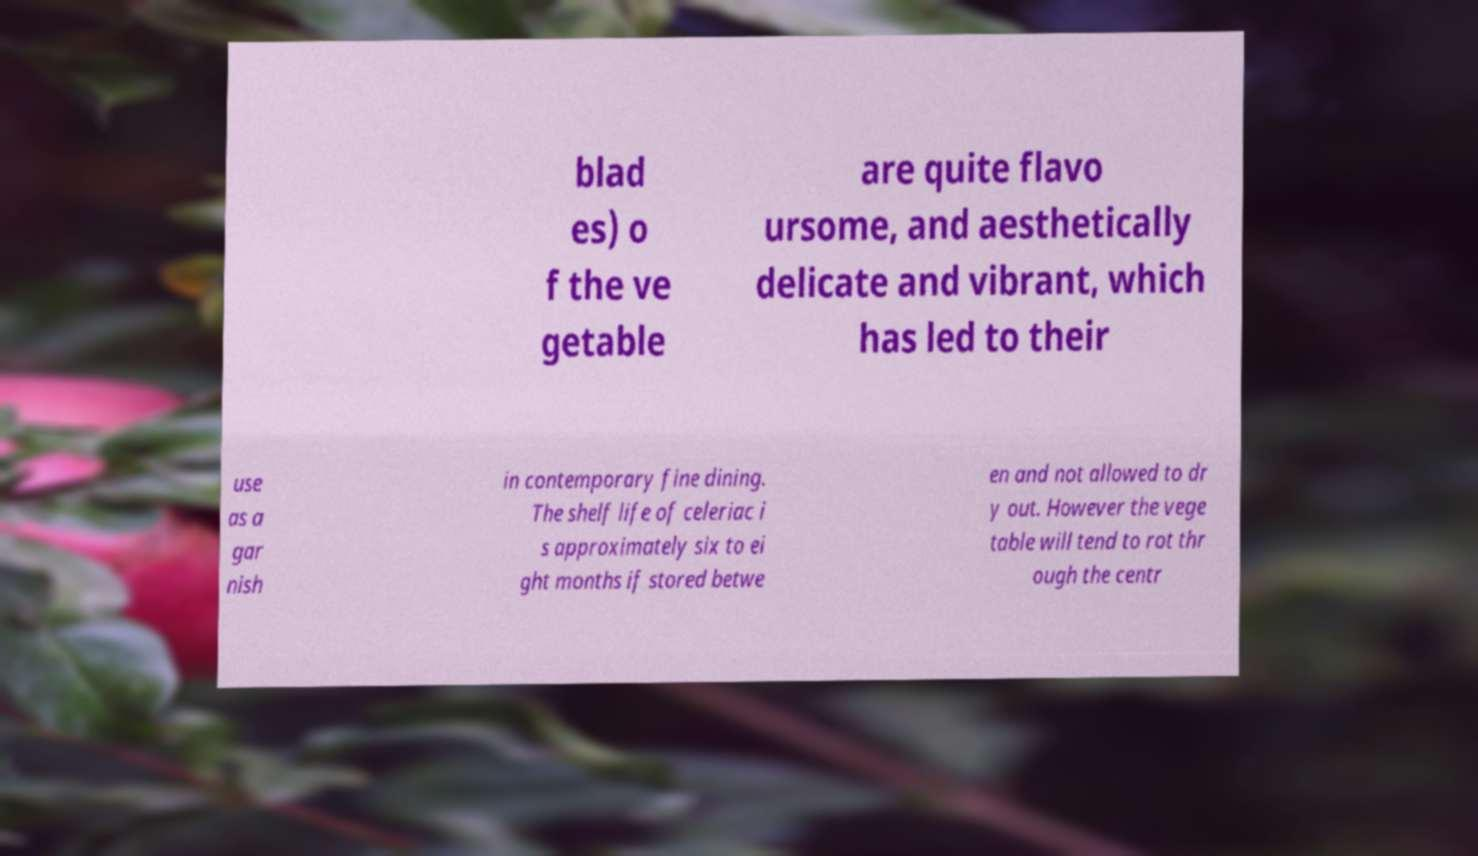Can you accurately transcribe the text from the provided image for me? blad es) o f the ve getable are quite flavo ursome, and aesthetically delicate and vibrant, which has led to their use as a gar nish in contemporary fine dining. The shelf life of celeriac i s approximately six to ei ght months if stored betwe en and not allowed to dr y out. However the vege table will tend to rot thr ough the centr 